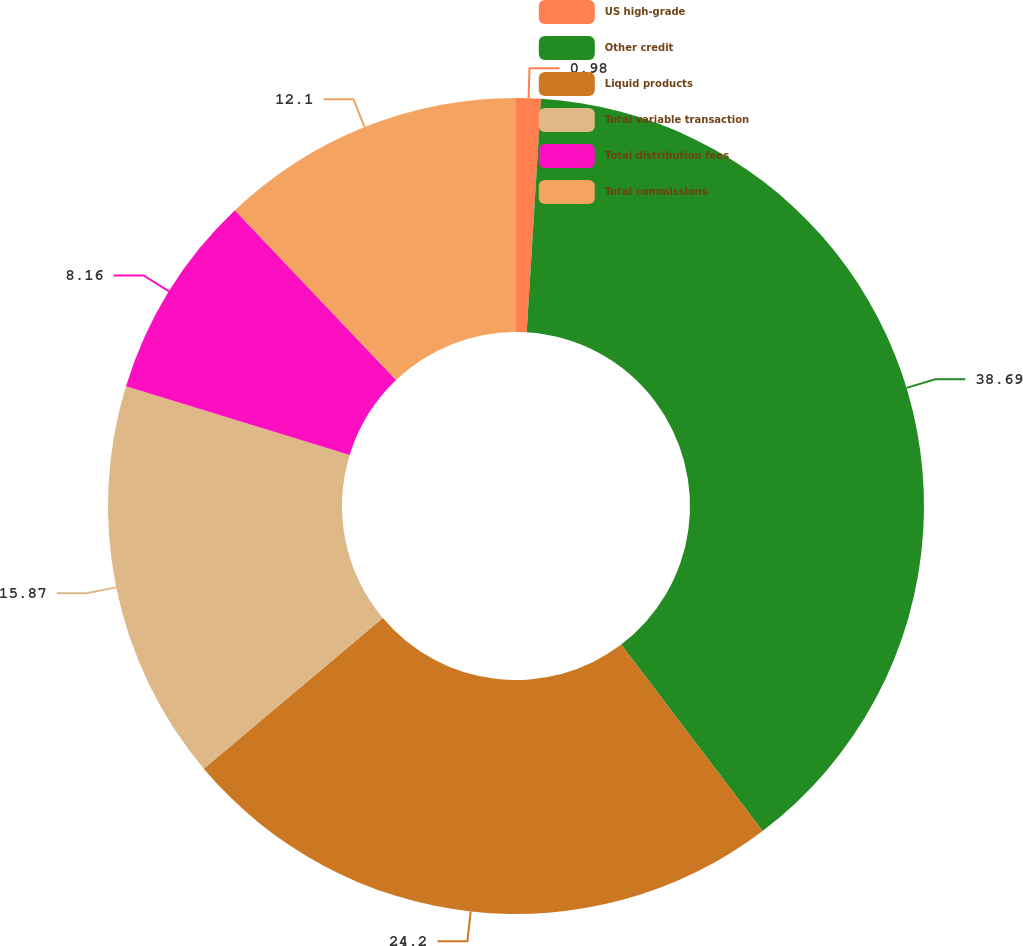Convert chart to OTSL. <chart><loc_0><loc_0><loc_500><loc_500><pie_chart><fcel>US high-grade<fcel>Other credit<fcel>Liquid products<fcel>Total variable transaction<fcel>Total distribution fees<fcel>Total commissions<nl><fcel>0.98%<fcel>38.69%<fcel>24.2%<fcel>15.87%<fcel>8.16%<fcel>12.1%<nl></chart> 